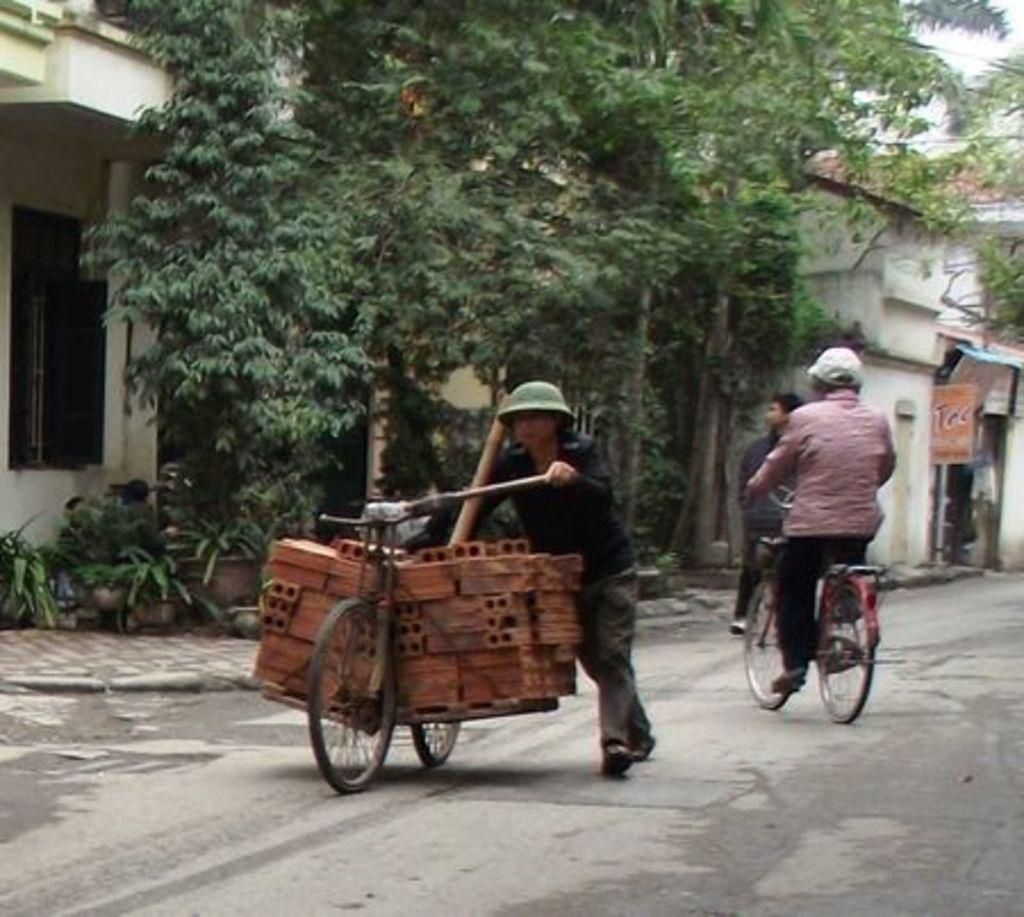What is the main subject of the image? There is a person in the image. What is the person doing in the image? The person is riding a bicycle. What is the person holding in the image? The person is holding something. What can be seen in the background of the image? There is a building and trees visible in the background. What type of books can be found in the library depicted in the image? There is no library present in the image, so it is not possible to determine what type of books might be found there. 